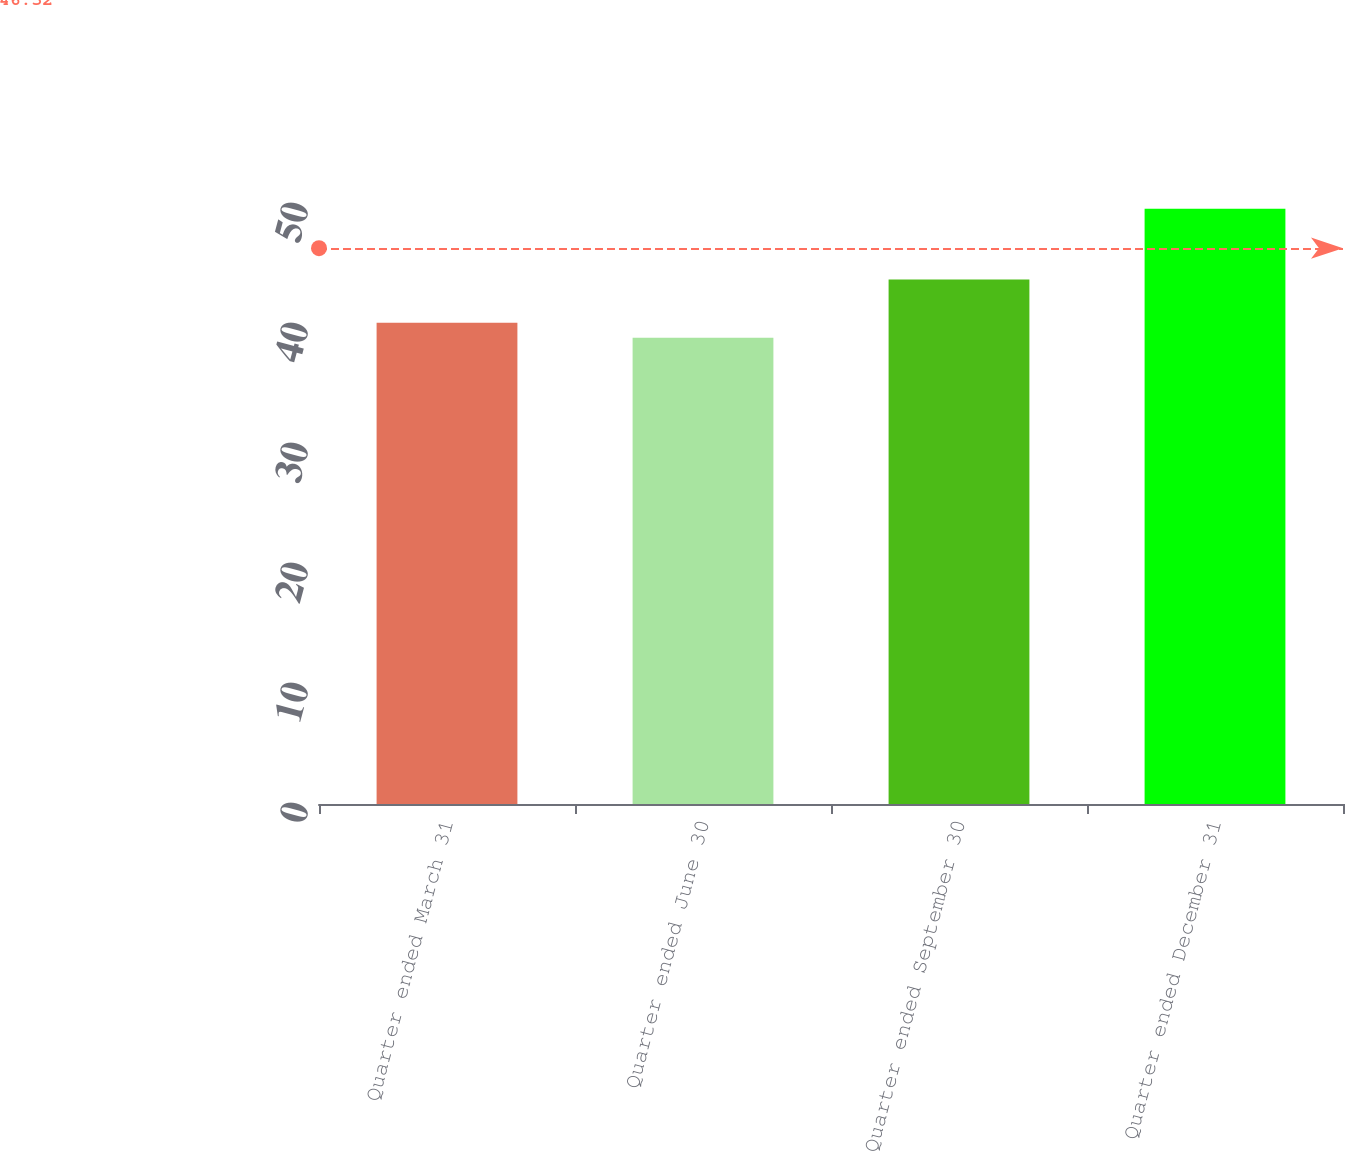Convert chart. <chart><loc_0><loc_0><loc_500><loc_500><bar_chart><fcel>Quarter ended March 31<fcel>Quarter ended June 30<fcel>Quarter ended September 30<fcel>Quarter ended December 31<nl><fcel>40.1<fcel>38.86<fcel>43.7<fcel>49.61<nl></chart> 